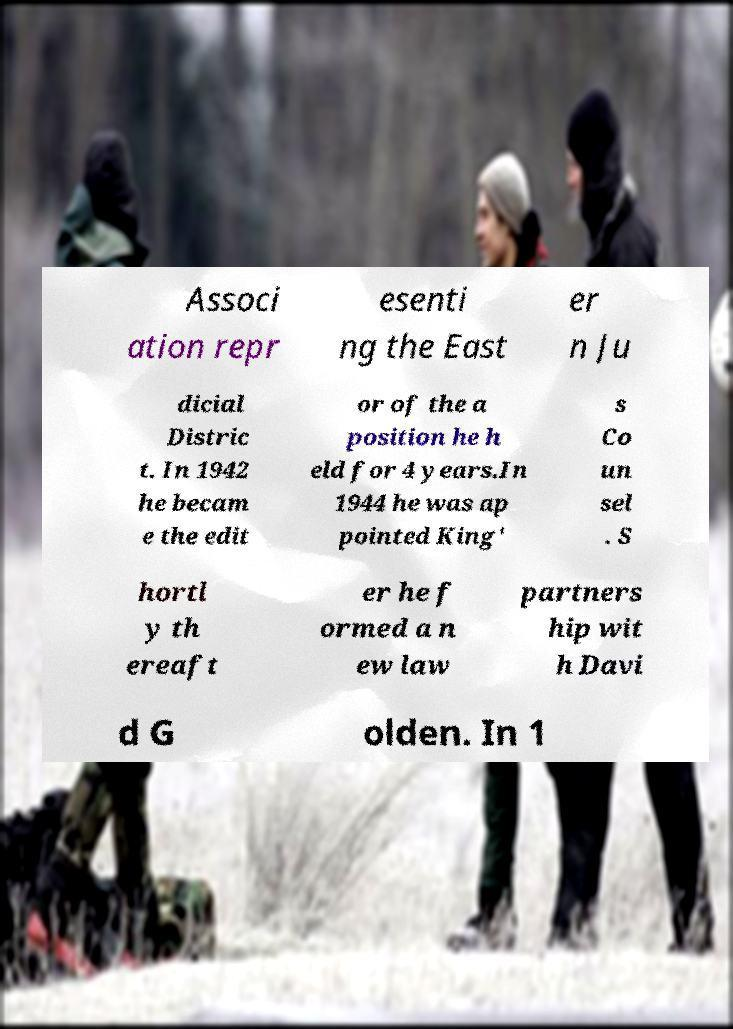I need the written content from this picture converted into text. Can you do that? Associ ation repr esenti ng the East er n Ju dicial Distric t. In 1942 he becam e the edit or of the a position he h eld for 4 years.In 1944 he was ap pointed King' s Co un sel . S hortl y th ereaft er he f ormed a n ew law partners hip wit h Davi d G olden. In 1 